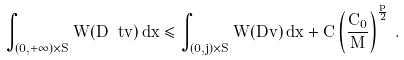Convert formula to latex. <formula><loc_0><loc_0><loc_500><loc_500>\int _ { ( 0 , + \infty ) \times S } W ( D \ t v ) \, d x \leq \int _ { ( 0 , j ) \times S } W ( D v ) \, d x + C \left ( \frac { C _ { 0 } } { M } \right ) ^ { \frac { p } { 2 } } \, .</formula> 